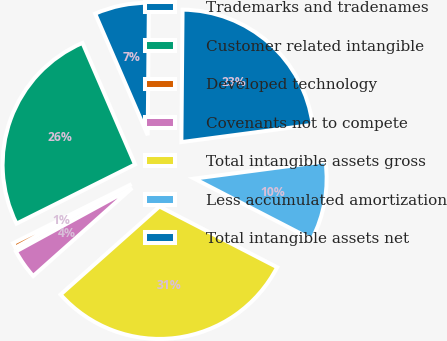Convert chart. <chart><loc_0><loc_0><loc_500><loc_500><pie_chart><fcel>Trademarks and tradenames<fcel>Customer related intangible<fcel>Developed technology<fcel>Covenants not to compete<fcel>Total intangible assets gross<fcel>Less accumulated amortization<fcel>Total intangible assets net<nl><fcel>6.64%<fcel>25.87%<fcel>0.59%<fcel>3.62%<fcel>30.84%<fcel>9.67%<fcel>22.77%<nl></chart> 